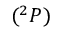Convert formula to latex. <formula><loc_0><loc_0><loc_500><loc_500>( ^ { 2 } P )</formula> 